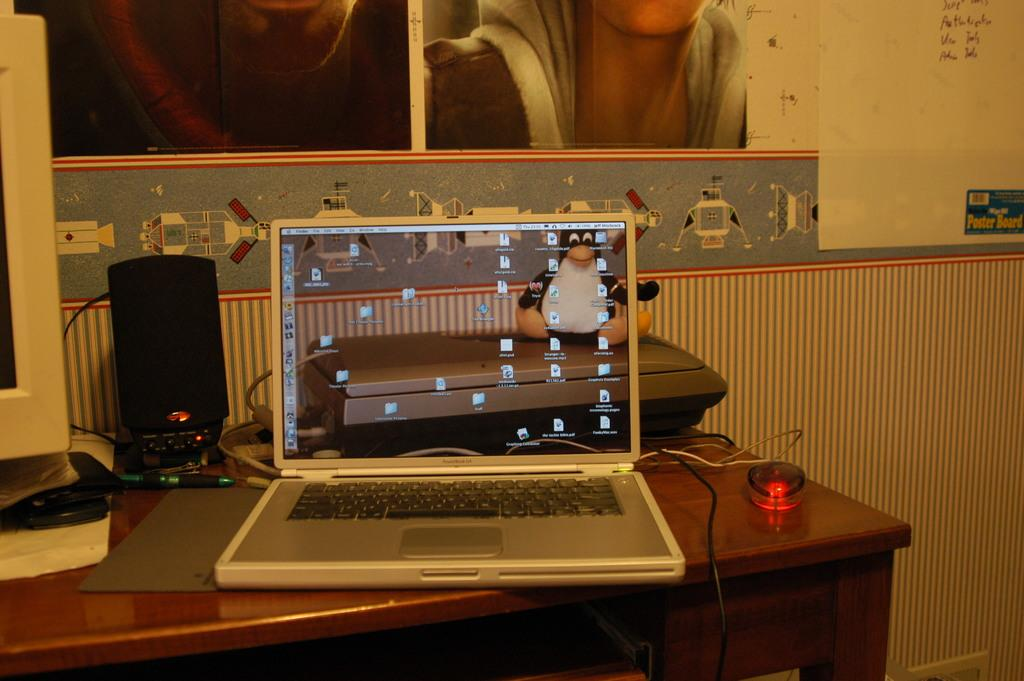What electronic device is visible in the image? There is a laptop in the image. What accessory is used with the laptop? There is a mouse in the image. What might be used to connect the laptop to other devices? There are wires in the image. What is used to amplify sound in the image? There are speakers in the image. What stationary object is present in the image? There is a pen in the image. What is used to display visuals from the laptop? There is a monitor in the image. Where are all these objects located? All these objects are on a table. What can be seen on the wall in the background of the image? There is a poster on the wall in the background of the image. How many pairs of shoes are visible in the image? There are no shoes visible in the image. What event is being celebrated in the image? There is no indication of a celebration or birth in the image. What type of insect can be seen crawling on the laptop in the image? There is no insect, such as a beetle, present in the image. 